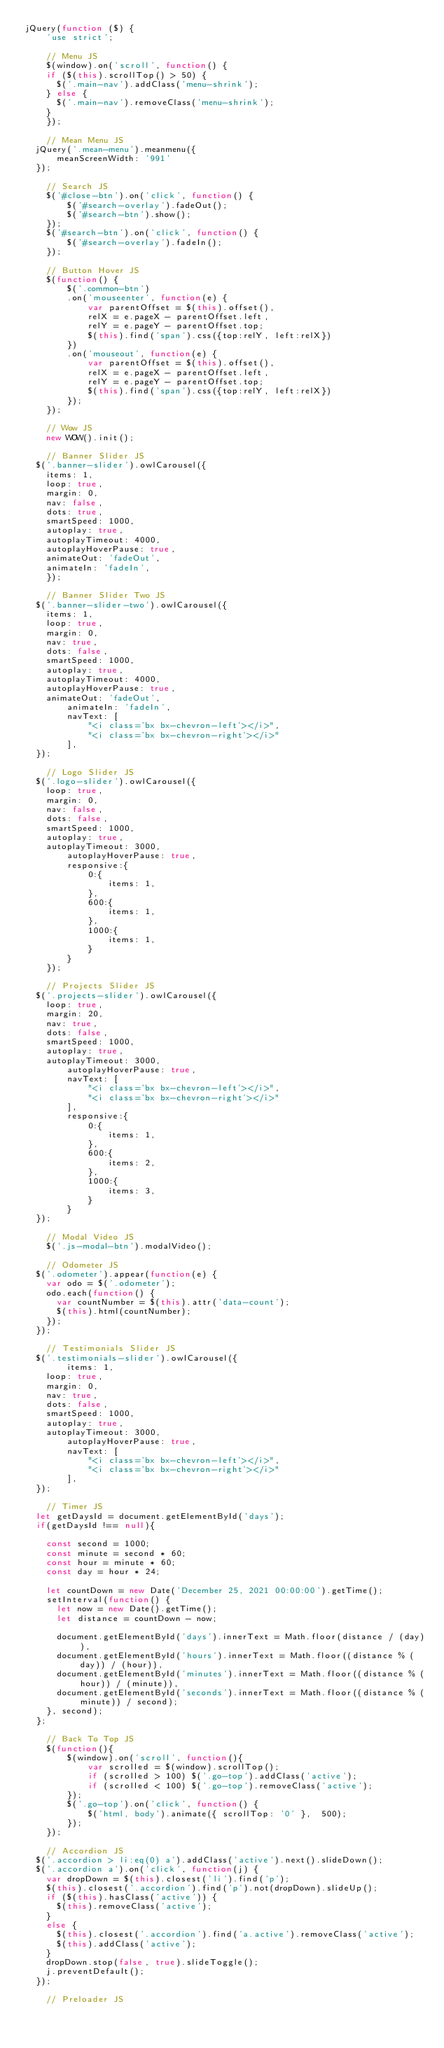Convert code to text. <code><loc_0><loc_0><loc_500><loc_500><_JavaScript_>jQuery(function ($) {
    'use strict';

    // Menu JS
    $(window).on('scroll', function() {
		if ($(this).scrollTop() > 50) {
			$('.main-nav').addClass('menu-shrink');
		} else {
			$('.main-nav').removeClass('menu-shrink');
		}
    });	

    // Mean Menu JS
	jQuery('.mean-menu').meanmenu({
	    meanScreenWidth: '991'
	});

    // Search JS
    $('#close-btn').on('click', function() {
        $('#search-overlay').fadeOut();
        $('#search-btn').show();
    });
    $('#search-btn').on('click', function() {
        $('#search-overlay').fadeIn();
    });

    // Button Hover JS
    $(function() {
        $('.common-btn')
        .on('mouseenter', function(e) {
            var parentOffset = $(this).offset(),
            relX = e.pageX - parentOffset.left,
            relY = e.pageY - parentOffset.top;
            $(this).find('span').css({top:relY, left:relX})
        })
        .on('mouseout', function(e) {
            var parentOffset = $(this).offset(),
            relX = e.pageX - parentOffset.left,
            relY = e.pageY - parentOffset.top;
            $(this).find('span').css({top:relY, left:relX})
        });
    });

    // Wow JS
    new WOW().init();

    // Banner Slider JS
	$('.banner-slider').owlCarousel({
		items: 1,
		loop: true,
		margin: 0,
		nav: false,
		dots: true,
		smartSpeed: 1000,
		autoplay: true,
		autoplayTimeout: 4000,
		autoplayHoverPause: true,
		animateOut: 'fadeOut',
		animateIn: 'fadeIn',
    });
    
    // Banner Slider Two JS
	$('.banner-slider-two').owlCarousel({
		items: 1,
		loop: true,
		margin: 0,
		nav: true,
		dots: false,
		smartSpeed: 1000,
		autoplay: true,
		autoplayTimeout: 4000,
		autoplayHoverPause: true,
		animateOut: 'fadeOut',
        animateIn: 'fadeIn',
        navText: [
            "<i class='bx bx-chevron-left'></i>",
            "<i class='bx bx-chevron-right'></i>"
        ],
	});

    // Logo Slider JS
	$('.logo-slider').owlCarousel({
		loop: true,
		margin: 0,
		nav: false,
		dots: false,
		smartSpeed: 1000,
		autoplay: true,
		autoplayTimeout: 3000,
        autoplayHoverPause: true,
        responsive:{
            0:{
                items: 1,
            },
            600:{
                items: 1,
            },
            1000:{
                items: 1,
            }
        }
    });
    
    // Projects Slider JS
	$('.projects-slider').owlCarousel({
		loop: true,
		margin: 20,
		nav: true,
		dots: false,
		smartSpeed: 1000,
		autoplay: true,
		autoplayTimeout: 3000,
        autoplayHoverPause: true,
        navText: [
            "<i class='bx bx-chevron-left'></i>",
            "<i class='bx bx-chevron-right'></i>"
        ],
        responsive:{
            0:{
                items: 1,
            },
            600:{
                items: 2,
            },
            1000:{
                items: 3,
            }
        }
	});

    // Modal Video JS
    $('.js-modal-btn').modalVideo();

    // Odometer JS
	$('.odometer').appear(function(e) {
		var odo = $('.odometer');
		odo.each(function() {
			var countNumber = $(this).attr('data-count');
			$(this).html(countNumber);
		});
	});

    // Testimonials Slider JS
	$('.testimonials-slider').owlCarousel({
        items: 1,
		loop: true,
		margin: 0,
		nav: true,
		dots: false,
		smartSpeed: 1000,
		autoplay: true,
		autoplayTimeout: 3000,
        autoplayHoverPause: true,
        navText: [
            "<i class='bx bx-chevron-left'></i>",
            "<i class='bx bx-chevron-right'></i>"
        ],
	});

    // Timer JS
	let getDaysId = document.getElementById('days');
	if(getDaysId !== null){
		
		const second = 1000;
		const minute = second * 60;
		const hour = minute * 60;
		const day = hour * 24;

		let countDown = new Date('December 25, 2021 00:00:00').getTime();
		setInterval(function() {
			let now = new Date().getTime();
			let distance = countDown - now;

			document.getElementById('days').innerText = Math.floor(distance / (day)),
			document.getElementById('hours').innerText = Math.floor((distance % (day)) / (hour)),
			document.getElementById('minutes').innerText = Math.floor((distance % (hour)) / (minute)),
			document.getElementById('seconds').innerText = Math.floor((distance % (minute)) / second);
		}, second);
	};

    // Back To Top JS
    $(function(){
        $(window).on('scroll', function(){
            var scrolled = $(window).scrollTop();
            if (scrolled > 100) $('.go-top').addClass('active');
            if (scrolled < 100) $('.go-top').removeClass('active');
        });  
        $('.go-top').on('click', function() {
            $('html, body').animate({ scrollTop: '0' },  500);
        });
    });

    // Accordion JS
	$('.accordion > li:eq(0) a').addClass('active').next().slideDown();
	$('.accordion a').on('click', function(j) {
		var dropDown = $(this).closest('li').find('p');
		$(this).closest('.accordion').find('p').not(dropDown).slideUp();
		if ($(this).hasClass('active')) {
			$(this).removeClass('active');
		} 
		else {
			$(this).closest('.accordion').find('a.active').removeClass('active');
			$(this).addClass('active');
		}
		dropDown.stop(false, true).slideToggle();
		j.preventDefault();
	});

    // Preloader JS</code> 